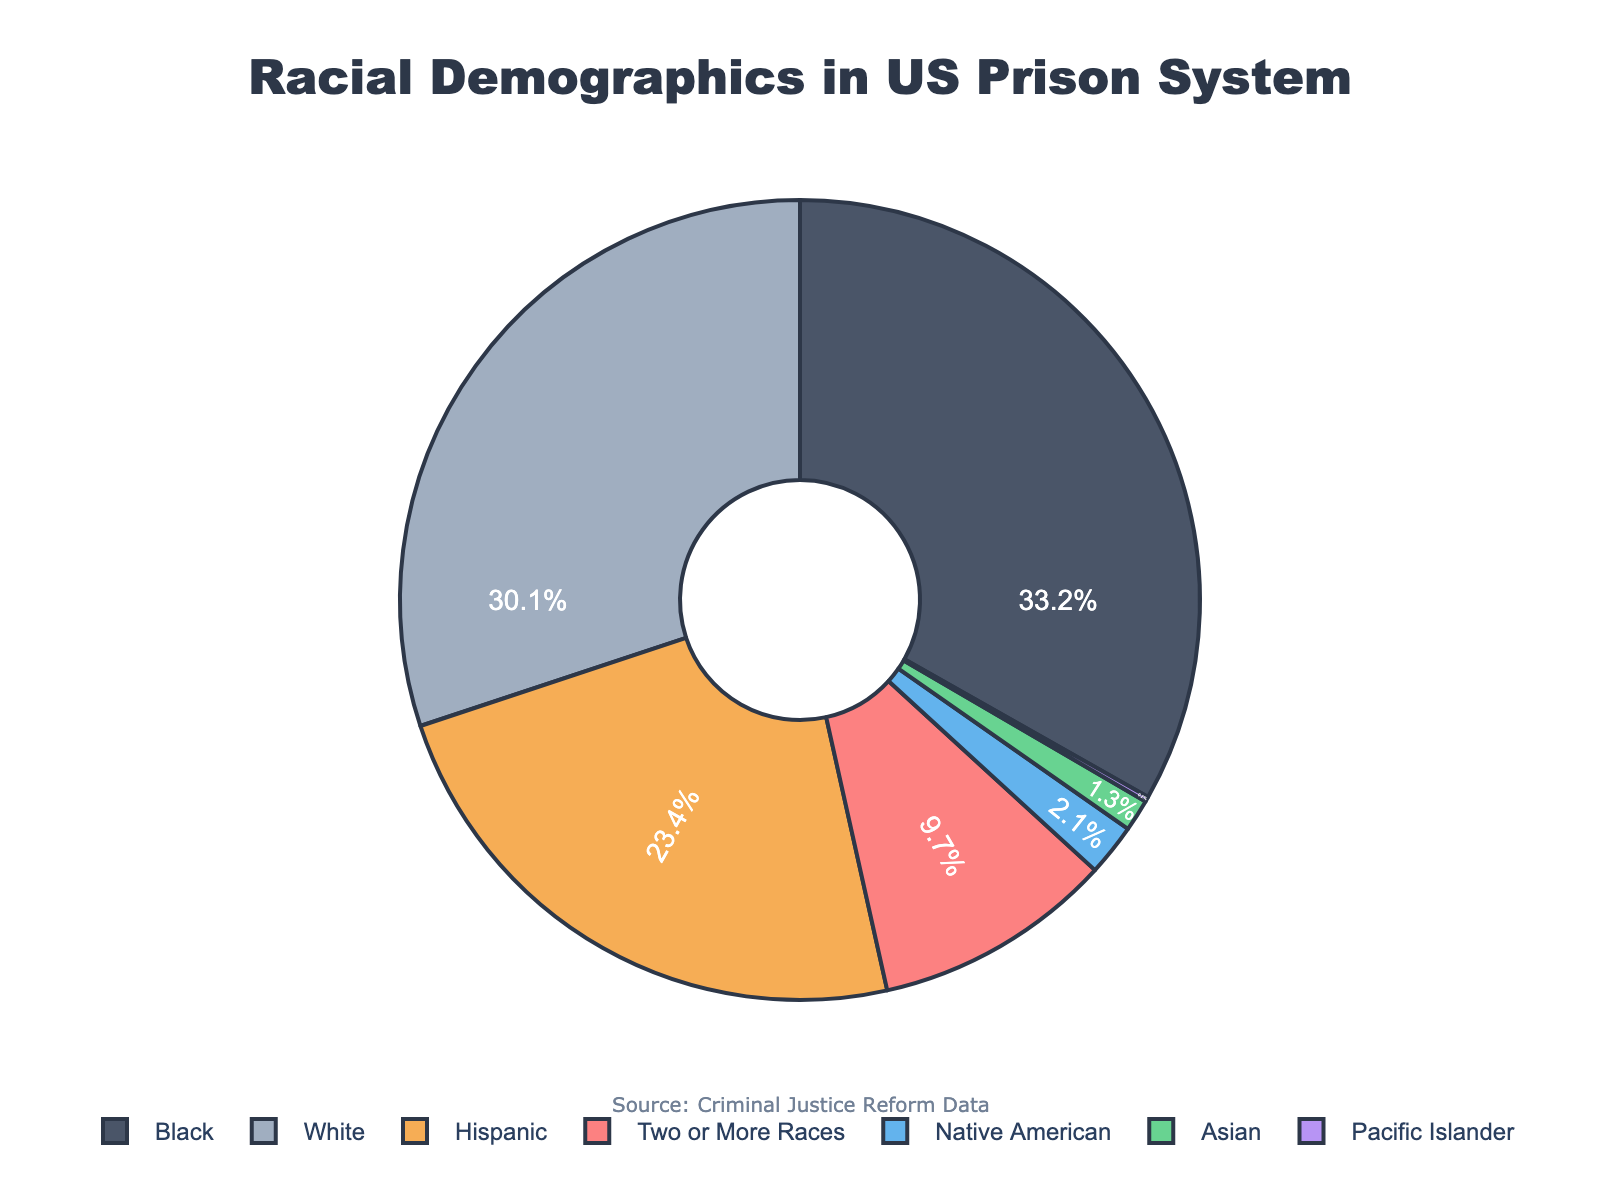what race has the highest percentage of incarcerated individuals in the US prison system? According to the pie chart, the race with the highest percentage of incarcerated individuals is Black, with 33.2%.
Answer: Black which two races have the lowest percentage of incarcerated individuals in the US prison system? The two races with the lowest percentages are Pacific Islander (0.2%) and Asian (1.3%).
Answer: Pacific Islander, Asian how does the percentage of Hispanic incarcerated individuals compare to the percentage of White incarcerated individuals? The percentage of Hispanic incarcerated individuals (23.4%) is less than the percentage of White incarcerated individuals (30.1%).
Answer: Less what is the combined percentage of incarcerated individuals who are either Black or Hispanic? Adding the percentages for Black (33.2%) and Hispanic (23.4%) gives us 33.2 + 23.4 = 56.6%.
Answer: 56.6% what percentage of incarcerated individuals identify as Two or More Races? The pie chart shows that 9.7% of incarcerated individuals identify as Two or More Races.
Answer: 9.7% how much greater is the percentage of Native American incarcerated individuals compared to Pacific Islander incarcerated individuals? Subtract the percentage of Pacific Islanders (0.2%) from the percentage of Native Americans (2.1%): 2.1 - 0.2 = 1.9%.
Answer: 1.9% what is the total percentage of incarcerated individuals for the groups that have percentages in single digits? Adding the percentages of Asian (1.3%), Native American (2.1%), Pacific Islander (0.2%), and Two or More Races (9.7%) results in: 1.3 + 2.1 + 0.2 + 9.7 = 13.3%.
Answer: 13.3% is the percentage of Black incarcerated individuals greater than the combined percentage of Native American and Hispanic incarcerated individuals? First, calculate the combined percentage of Native American (2.1%) and Hispanic (23.4%): 2.1 + 23.4 = 25.5%. Since 33.2% (Black) is greater than 25.5%, the answer is yes.
Answer: Yes how does the segment color for Two or More Races compare to the segment color for White? Visually, the segment for Two or More Races is in a different color shade than the segment for White, as indicated by the distinct colors in the pie chart.
Answer: Different color 